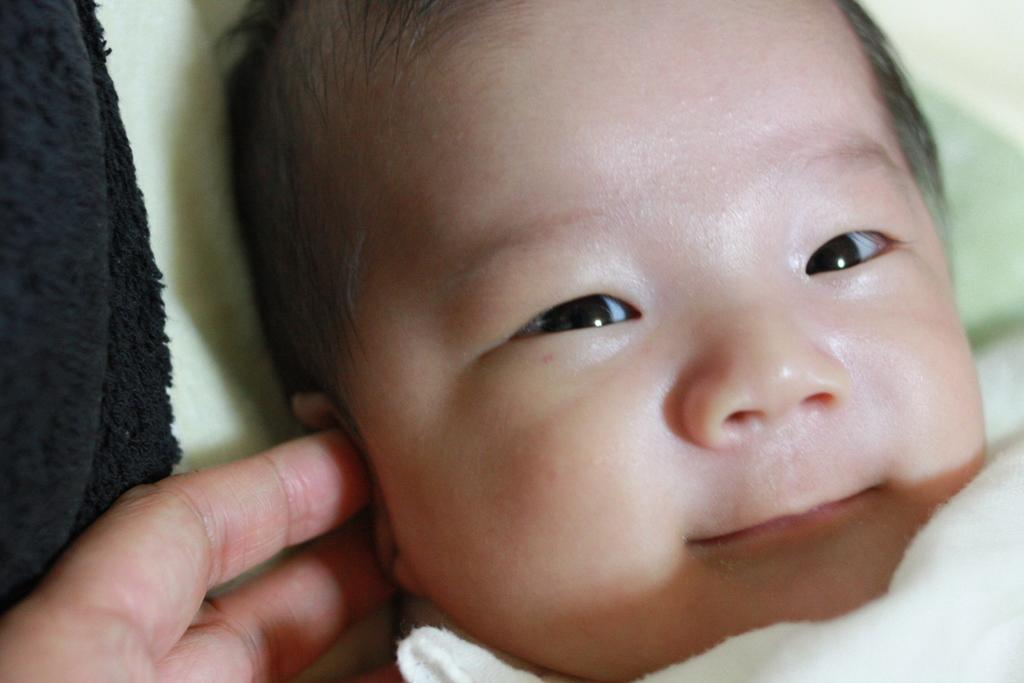What is the main subject of the image? There is a baby's face in the image. What is the person in the image doing? A person's hand is touching the baby's ear. What can be seen in the background of the image? There is a light green color carpet behind the baby. What type of watch is the carpenter wearing in the image? There is no carpenter or watch present in the image. What is the relation between the baby and the person touching the ear in the image? The facts provided do not give any information about the relationship between the baby and the person touching the ear. 